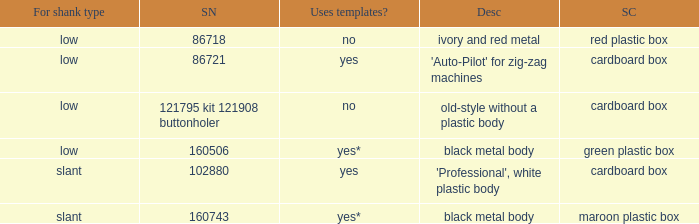What's the storage case of the buttonholer described as ivory and red metal? Red plastic box. 